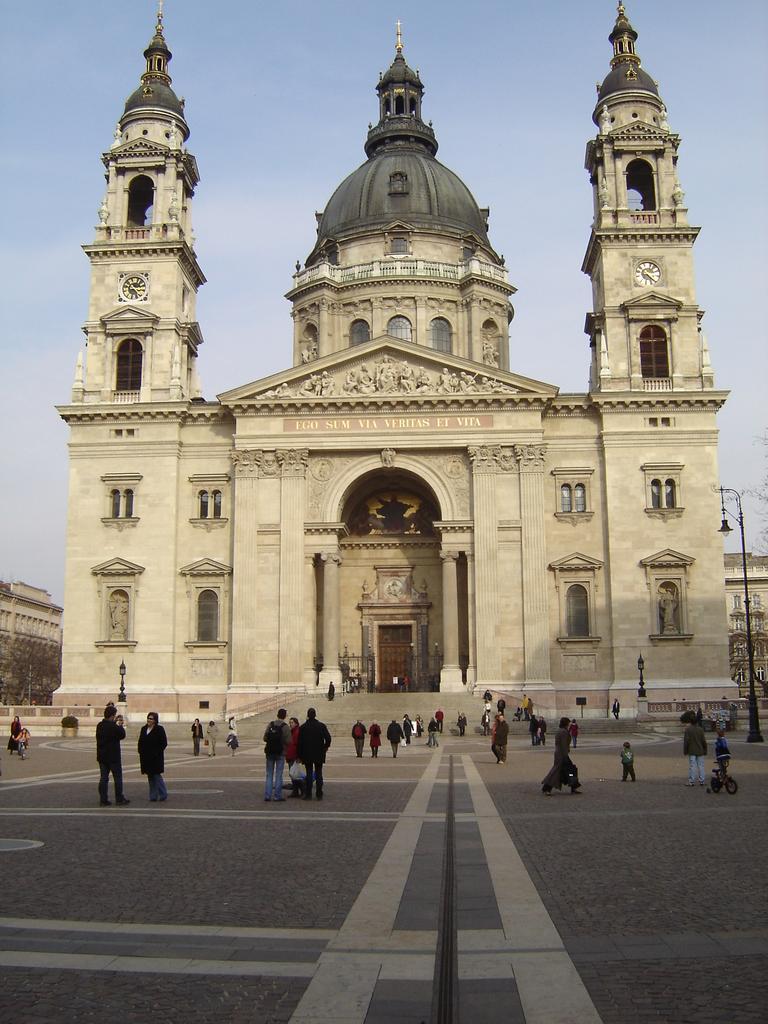Could you give a brief overview of what you see in this image? In this image in the center there is one palace and at the bottom there is a walkway, on the walkway there are some people who are walking and some of them are standing and on the right side there is one pole. On the top of the image there is sky. 